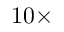<formula> <loc_0><loc_0><loc_500><loc_500>1 0 \times</formula> 